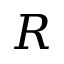Convert formula to latex. <formula><loc_0><loc_0><loc_500><loc_500>R</formula> 